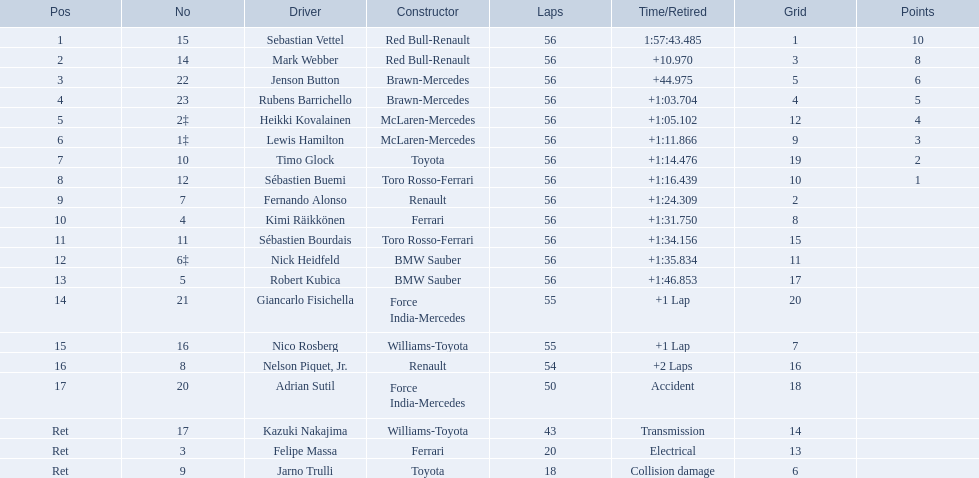Which drivers took part in the 2009 chinese grand prix? Sebastian Vettel, Mark Webber, Jenson Button, Rubens Barrichello, Heikki Kovalainen, Lewis Hamilton, Timo Glock, Sébastien Buemi, Fernando Alonso, Kimi Räikkönen, Sébastien Bourdais, Nick Heidfeld, Robert Kubica, Giancarlo Fisichella, Nico Rosberg, Nelson Piquet, Jr., Adrian Sutil, Kazuki Nakajima, Felipe Massa, Jarno Trulli. Of these, who completed all 56 laps? Sebastian Vettel, Mark Webber, Jenson Button, Rubens Barrichello, Heikki Kovalainen, Lewis Hamilton, Timo Glock, Sébastien Buemi, Fernando Alonso, Kimi Räikkönen, Sébastien Bourdais, Nick Heidfeld, Robert Kubica. Of these, which did ferrari not participate as a constructor? Sebastian Vettel, Mark Webber, Jenson Button, Rubens Barrichello, Heikki Kovalainen, Lewis Hamilton, Timo Glock, Fernando Alonso, Kimi Räikkönen, Nick Heidfeld, Robert Kubica. Of the remaining, which is in pos 1? Sebastian Vettel. Who participated as drivers in the 2009 chinese grand prix? Sebastian Vettel, Mark Webber, Jenson Button, Rubens Barrichello, Heikki Kovalainen, Lewis Hamilton, Timo Glock, Sébastien Buemi, Fernando Alonso, Kimi Räikkönen, Sébastien Bourdais, Nick Heidfeld, Robert Kubica, Giancarlo Fisichella, Nico Rosberg, Nelson Piquet, Jr., Adrian Sutil, Kazuki Nakajima, Felipe Massa, Jarno Trulli. What were their end times? 1:57:43.485, +10.970, +44.975, +1:03.704, +1:05.102, +1:11.866, +1:14.476, +1:16.439, +1:24.309, +1:31.750, +1:34.156, +1:35.834, +1:46.853, +1 Lap, +1 Lap, +2 Laps, Accident, Transmission, Electrical, Collision damage. Which competitor encountered collision damage and had to retire? Jarno Trulli. Who were the participating drivers? Sebastian Vettel, Mark Webber, Jenson Button, Rubens Barrichello, Heikki Kovalainen, Lewis Hamilton, Timo Glock, Sébastien Buemi, Fernando Alonso, Kimi Räikkönen, Sébastien Bourdais, Nick Heidfeld, Robert Kubica, Giancarlo Fisichella, Nico Rosberg, Nelson Piquet, Jr., Adrian Sutil, Kazuki Nakajima, Felipe Massa, Jarno Trulli. What were their respective finishing times? 1:57:43.485, +10.970, +44.975, +1:03.704, +1:05.102, +1:11.866, +1:14.476, +1:16.439, +1:24.309, +1:31.750, +1:34.156, +1:35.834, +1:46.853, +1 Lap, +1 Lap, +2 Laps, Accident, Transmission, Electrical, Collision damage. Who was the last one to finish? Robert Kubica. 